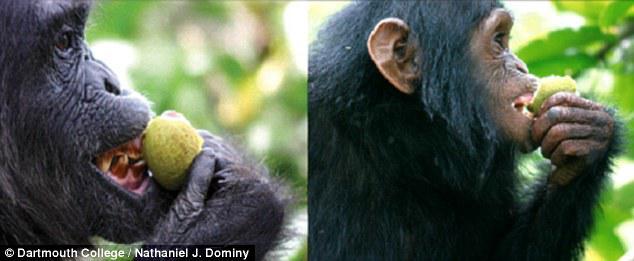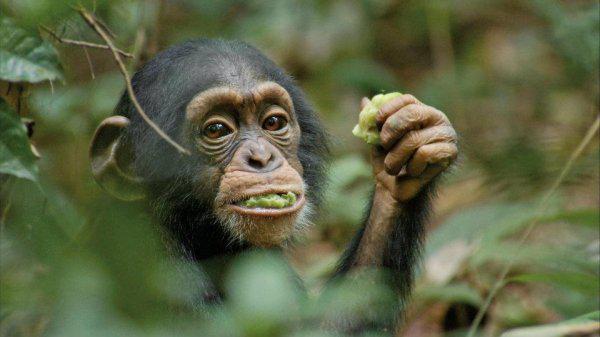The first image is the image on the left, the second image is the image on the right. Assess this claim about the two images: "There is green food in the mouth of the monkey in the image on the right.". Correct or not? Answer yes or no. Yes. 